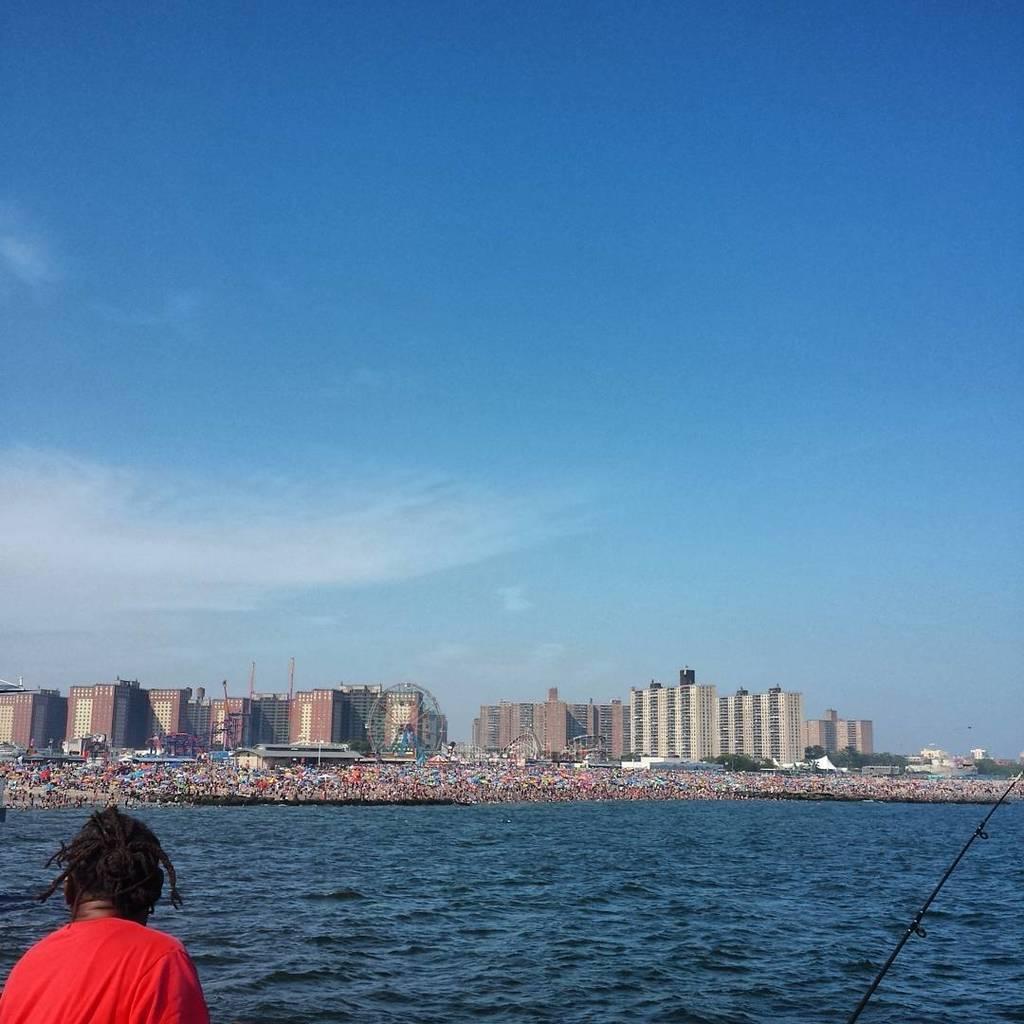Can you describe this image briefly? In this image I can see a person wearing red color shirt, background I can see water, buildings in white color and sky in blue and white color. 